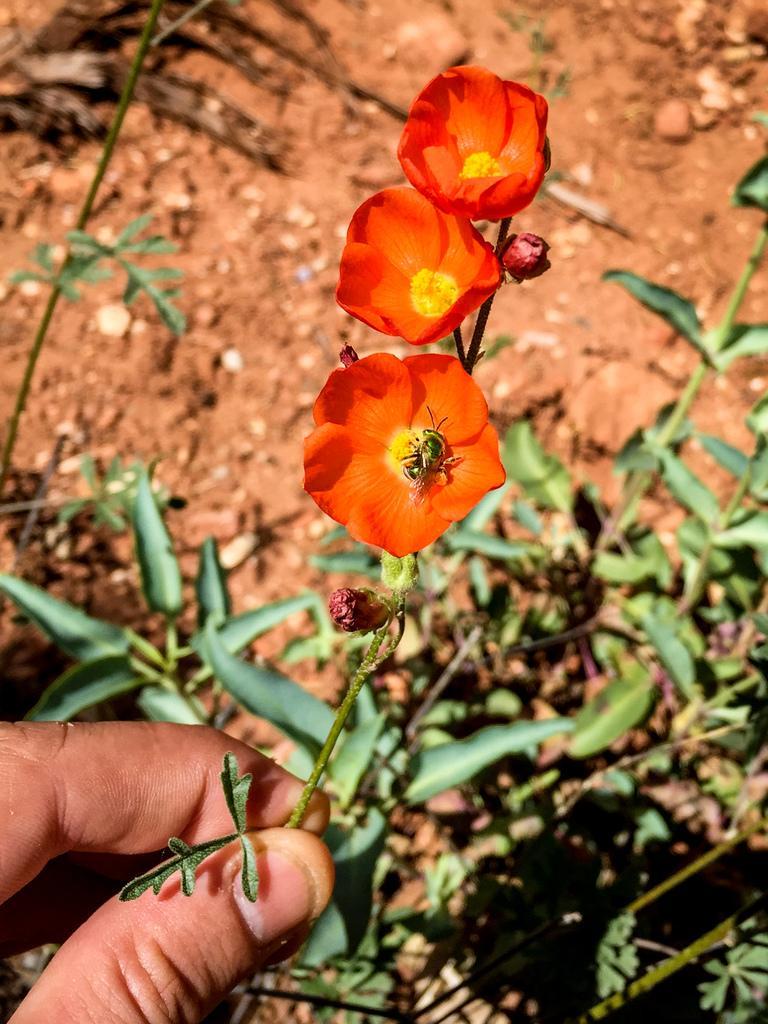Describe this image in one or two sentences. In this image we can see a human hand is holding orange color flowers. Background of the image leaves and stems are present and sandy land is there. 